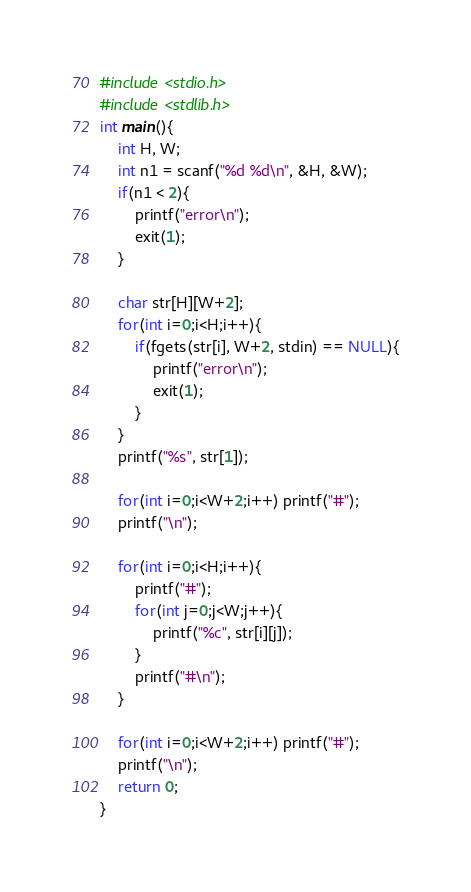Convert code to text. <code><loc_0><loc_0><loc_500><loc_500><_C_>#include <stdio.h>
#include <stdlib.h>
int main(){
	int H, W;
	int n1 = scanf("%d %d\n", &H, &W);
	if(n1 < 2){
		printf("error\n");
		exit(1);
	}
	
	char str[H][W+2];
	for(int i=0;i<H;i++){
		if(fgets(str[i], W+2, stdin) == NULL){
			printf("error\n");
			exit(1);
		}
	}
	printf("%s", str[1]);

	for(int i=0;i<W+2;i++) printf("#");
	printf("\n");

	for(int i=0;i<H;i++){
		printf("#");
		for(int j=0;j<W;j++){
			printf("%c", str[i][j]);
		}
		printf("#\n");
	}

	for(int i=0;i<W+2;i++) printf("#");
	printf("\n");
	return 0;
}</code> 